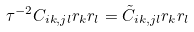<formula> <loc_0><loc_0><loc_500><loc_500>\tau ^ { - 2 } C _ { i k , j l } r _ { k } r _ { l } = \tilde { C } _ { i k , j l } r _ { k } r _ { l }</formula> 